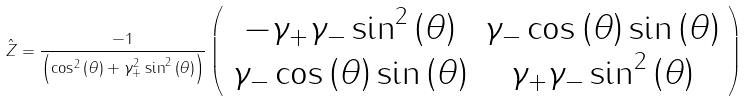Convert formula to latex. <formula><loc_0><loc_0><loc_500><loc_500>\hat { Z } = \frac { - 1 } { \left ( \cos ^ { 2 } \left ( \theta \right ) + \gamma _ { + } ^ { 2 } \sin ^ { 2 } \left ( \theta \right ) \right ) } \left ( \begin{array} { c c } { { - \gamma _ { + } \gamma _ { - } \sin ^ { 2 } \left ( \theta \right ) } } & { { \gamma _ { - } \cos \left ( \theta \right ) \sin \left ( \theta \right ) } } \\ { { \gamma _ { - } \cos \left ( \theta \right ) \sin \left ( \theta \right ) } } & { { \gamma _ { + } \gamma _ { - } \sin ^ { 2 } \left ( \theta \right ) } } \end{array} \right )</formula> 